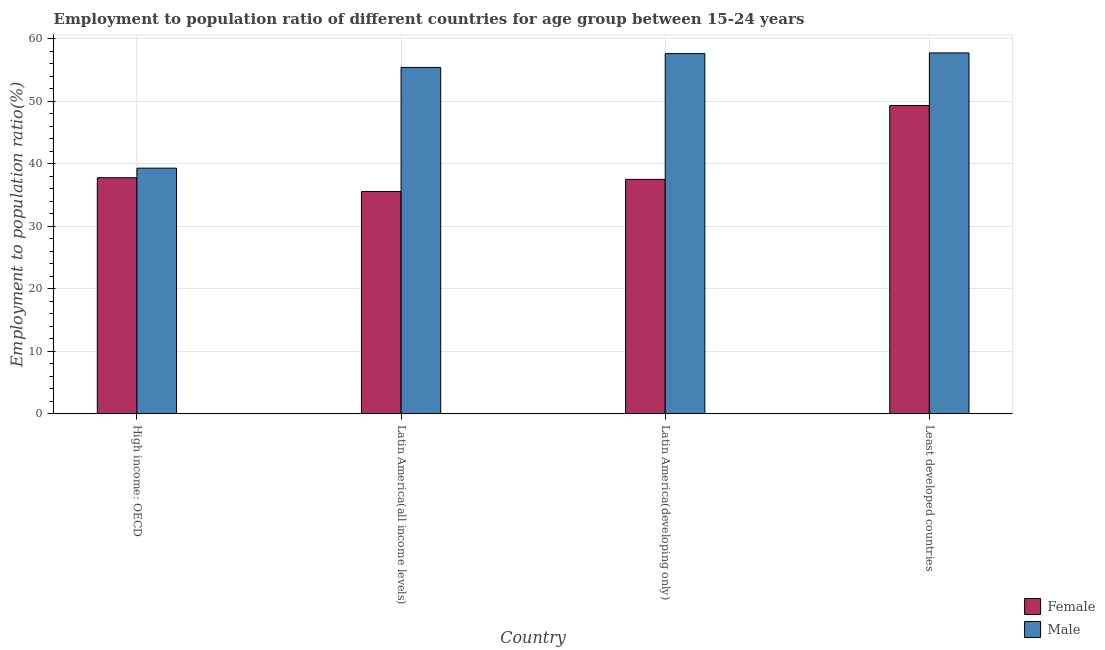How many different coloured bars are there?
Offer a very short reply. 2. Are the number of bars on each tick of the X-axis equal?
Make the answer very short. Yes. How many bars are there on the 2nd tick from the left?
Your answer should be compact. 2. How many bars are there on the 1st tick from the right?
Make the answer very short. 2. What is the label of the 3rd group of bars from the left?
Ensure brevity in your answer.  Latin America(developing only). What is the employment to population ratio(male) in Latin America(all income levels)?
Your answer should be compact. 55.44. Across all countries, what is the maximum employment to population ratio(male)?
Offer a very short reply. 57.76. Across all countries, what is the minimum employment to population ratio(female)?
Your answer should be compact. 35.58. In which country was the employment to population ratio(male) maximum?
Give a very brief answer. Least developed countries. In which country was the employment to population ratio(male) minimum?
Your answer should be compact. High income: OECD. What is the total employment to population ratio(male) in the graph?
Offer a terse response. 210.16. What is the difference between the employment to population ratio(female) in Latin America(all income levels) and that in Latin America(developing only)?
Give a very brief answer. -1.94. What is the difference between the employment to population ratio(male) in Latin America(all income levels) and the employment to population ratio(female) in Least developed countries?
Offer a terse response. 6.09. What is the average employment to population ratio(male) per country?
Keep it short and to the point. 52.54. What is the difference between the employment to population ratio(female) and employment to population ratio(male) in Latin America(all income levels)?
Give a very brief answer. -19.86. What is the ratio of the employment to population ratio(female) in Latin America(all income levels) to that in Latin America(developing only)?
Your answer should be compact. 0.95. Is the difference between the employment to population ratio(male) in Latin America(all income levels) and Least developed countries greater than the difference between the employment to population ratio(female) in Latin America(all income levels) and Least developed countries?
Make the answer very short. Yes. What is the difference between the highest and the second highest employment to population ratio(female)?
Provide a short and direct response. 11.57. What is the difference between the highest and the lowest employment to population ratio(male)?
Offer a very short reply. 18.45. Is the sum of the employment to population ratio(male) in High income: OECD and Least developed countries greater than the maximum employment to population ratio(female) across all countries?
Ensure brevity in your answer.  Yes. Does the graph contain any zero values?
Your response must be concise. No. How many legend labels are there?
Offer a terse response. 2. How are the legend labels stacked?
Your response must be concise. Vertical. What is the title of the graph?
Ensure brevity in your answer.  Employment to population ratio of different countries for age group between 15-24 years. What is the label or title of the X-axis?
Your answer should be very brief. Country. What is the label or title of the Y-axis?
Keep it short and to the point. Employment to population ratio(%). What is the Employment to population ratio(%) in Female in High income: OECD?
Your answer should be very brief. 37.78. What is the Employment to population ratio(%) of Male in High income: OECD?
Offer a terse response. 39.31. What is the Employment to population ratio(%) of Female in Latin America(all income levels)?
Provide a short and direct response. 35.58. What is the Employment to population ratio(%) of Male in Latin America(all income levels)?
Provide a succinct answer. 55.44. What is the Employment to population ratio(%) in Female in Latin America(developing only)?
Provide a succinct answer. 37.52. What is the Employment to population ratio(%) in Male in Latin America(developing only)?
Keep it short and to the point. 57.65. What is the Employment to population ratio(%) in Female in Least developed countries?
Your response must be concise. 49.35. What is the Employment to population ratio(%) of Male in Least developed countries?
Offer a very short reply. 57.76. Across all countries, what is the maximum Employment to population ratio(%) of Female?
Ensure brevity in your answer.  49.35. Across all countries, what is the maximum Employment to population ratio(%) of Male?
Your response must be concise. 57.76. Across all countries, what is the minimum Employment to population ratio(%) in Female?
Your answer should be very brief. 35.58. Across all countries, what is the minimum Employment to population ratio(%) in Male?
Give a very brief answer. 39.31. What is the total Employment to population ratio(%) of Female in the graph?
Your response must be concise. 160.22. What is the total Employment to population ratio(%) in Male in the graph?
Ensure brevity in your answer.  210.16. What is the difference between the Employment to population ratio(%) in Female in High income: OECD and that in Latin America(all income levels)?
Offer a terse response. 2.2. What is the difference between the Employment to population ratio(%) of Male in High income: OECD and that in Latin America(all income levels)?
Ensure brevity in your answer.  -16.13. What is the difference between the Employment to population ratio(%) in Female in High income: OECD and that in Latin America(developing only)?
Your answer should be very brief. 0.26. What is the difference between the Employment to population ratio(%) of Male in High income: OECD and that in Latin America(developing only)?
Make the answer very short. -18.34. What is the difference between the Employment to population ratio(%) in Female in High income: OECD and that in Least developed countries?
Make the answer very short. -11.57. What is the difference between the Employment to population ratio(%) of Male in High income: OECD and that in Least developed countries?
Your answer should be compact. -18.45. What is the difference between the Employment to population ratio(%) of Female in Latin America(all income levels) and that in Latin America(developing only)?
Your answer should be very brief. -1.94. What is the difference between the Employment to population ratio(%) of Male in Latin America(all income levels) and that in Latin America(developing only)?
Your answer should be compact. -2.21. What is the difference between the Employment to population ratio(%) in Female in Latin America(all income levels) and that in Least developed countries?
Provide a succinct answer. -13.76. What is the difference between the Employment to population ratio(%) of Male in Latin America(all income levels) and that in Least developed countries?
Provide a short and direct response. -2.32. What is the difference between the Employment to population ratio(%) of Female in Latin America(developing only) and that in Least developed countries?
Make the answer very short. -11.83. What is the difference between the Employment to population ratio(%) in Male in Latin America(developing only) and that in Least developed countries?
Offer a terse response. -0.11. What is the difference between the Employment to population ratio(%) of Female in High income: OECD and the Employment to population ratio(%) of Male in Latin America(all income levels)?
Keep it short and to the point. -17.66. What is the difference between the Employment to population ratio(%) in Female in High income: OECD and the Employment to population ratio(%) in Male in Latin America(developing only)?
Your answer should be very brief. -19.87. What is the difference between the Employment to population ratio(%) of Female in High income: OECD and the Employment to population ratio(%) of Male in Least developed countries?
Provide a succinct answer. -19.98. What is the difference between the Employment to population ratio(%) of Female in Latin America(all income levels) and the Employment to population ratio(%) of Male in Latin America(developing only)?
Your response must be concise. -22.07. What is the difference between the Employment to population ratio(%) in Female in Latin America(all income levels) and the Employment to population ratio(%) in Male in Least developed countries?
Ensure brevity in your answer.  -22.18. What is the difference between the Employment to population ratio(%) of Female in Latin America(developing only) and the Employment to population ratio(%) of Male in Least developed countries?
Ensure brevity in your answer.  -20.24. What is the average Employment to population ratio(%) of Female per country?
Make the answer very short. 40.06. What is the average Employment to population ratio(%) in Male per country?
Keep it short and to the point. 52.54. What is the difference between the Employment to population ratio(%) of Female and Employment to population ratio(%) of Male in High income: OECD?
Ensure brevity in your answer.  -1.53. What is the difference between the Employment to population ratio(%) of Female and Employment to population ratio(%) of Male in Latin America(all income levels)?
Give a very brief answer. -19.86. What is the difference between the Employment to population ratio(%) of Female and Employment to population ratio(%) of Male in Latin America(developing only)?
Offer a very short reply. -20.13. What is the difference between the Employment to population ratio(%) in Female and Employment to population ratio(%) in Male in Least developed countries?
Give a very brief answer. -8.42. What is the ratio of the Employment to population ratio(%) in Female in High income: OECD to that in Latin America(all income levels)?
Make the answer very short. 1.06. What is the ratio of the Employment to population ratio(%) of Male in High income: OECD to that in Latin America(all income levels)?
Provide a short and direct response. 0.71. What is the ratio of the Employment to population ratio(%) in Male in High income: OECD to that in Latin America(developing only)?
Ensure brevity in your answer.  0.68. What is the ratio of the Employment to population ratio(%) in Female in High income: OECD to that in Least developed countries?
Provide a short and direct response. 0.77. What is the ratio of the Employment to population ratio(%) in Male in High income: OECD to that in Least developed countries?
Your response must be concise. 0.68. What is the ratio of the Employment to population ratio(%) in Female in Latin America(all income levels) to that in Latin America(developing only)?
Your response must be concise. 0.95. What is the ratio of the Employment to population ratio(%) in Male in Latin America(all income levels) to that in Latin America(developing only)?
Offer a terse response. 0.96. What is the ratio of the Employment to population ratio(%) of Female in Latin America(all income levels) to that in Least developed countries?
Your answer should be compact. 0.72. What is the ratio of the Employment to population ratio(%) in Male in Latin America(all income levels) to that in Least developed countries?
Give a very brief answer. 0.96. What is the ratio of the Employment to population ratio(%) in Female in Latin America(developing only) to that in Least developed countries?
Give a very brief answer. 0.76. What is the ratio of the Employment to population ratio(%) of Male in Latin America(developing only) to that in Least developed countries?
Ensure brevity in your answer.  1. What is the difference between the highest and the second highest Employment to population ratio(%) in Female?
Offer a terse response. 11.57. What is the difference between the highest and the second highest Employment to population ratio(%) of Male?
Offer a very short reply. 0.11. What is the difference between the highest and the lowest Employment to population ratio(%) of Female?
Ensure brevity in your answer.  13.76. What is the difference between the highest and the lowest Employment to population ratio(%) in Male?
Offer a terse response. 18.45. 